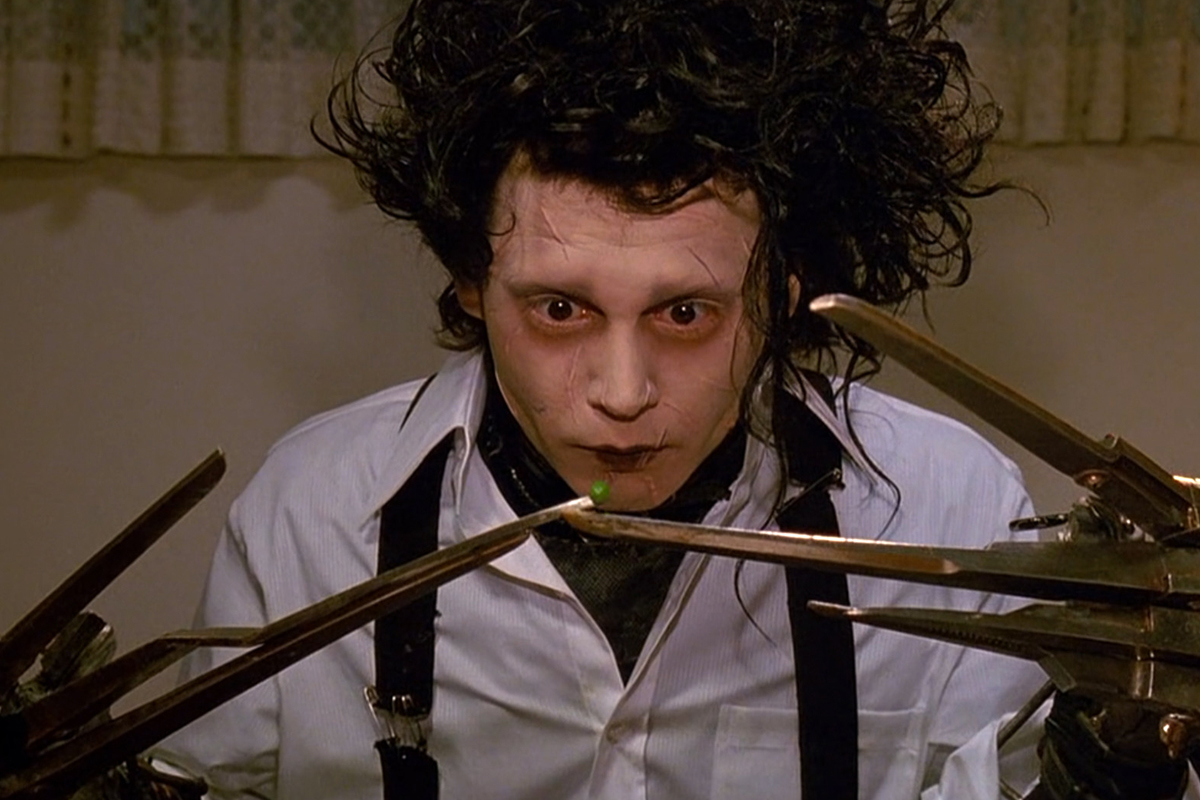What are the key elements in this picture? This poignant image captures a character from the movie 'Edward Scissorhands,' expertly portrayed by Johnny Depp. The frame focuses on Depp's character, Edward, with his pale face, dark eyes, and spiky, unkempt hair, creating a stark visual. Edward's most striking feature, his hands made of scissors, dominate the foreground, centered around a single green pea delicately balanced on one of the blades. Dressed in a crisp white shirt and black tie, Edward's attire contrasts his sorrowful expression, a staple of his misunderstood and unique persona. The surrounding background details, like the muted patterned curtain, subtly enhance the scene without detracting from Edward's compelling presence. 